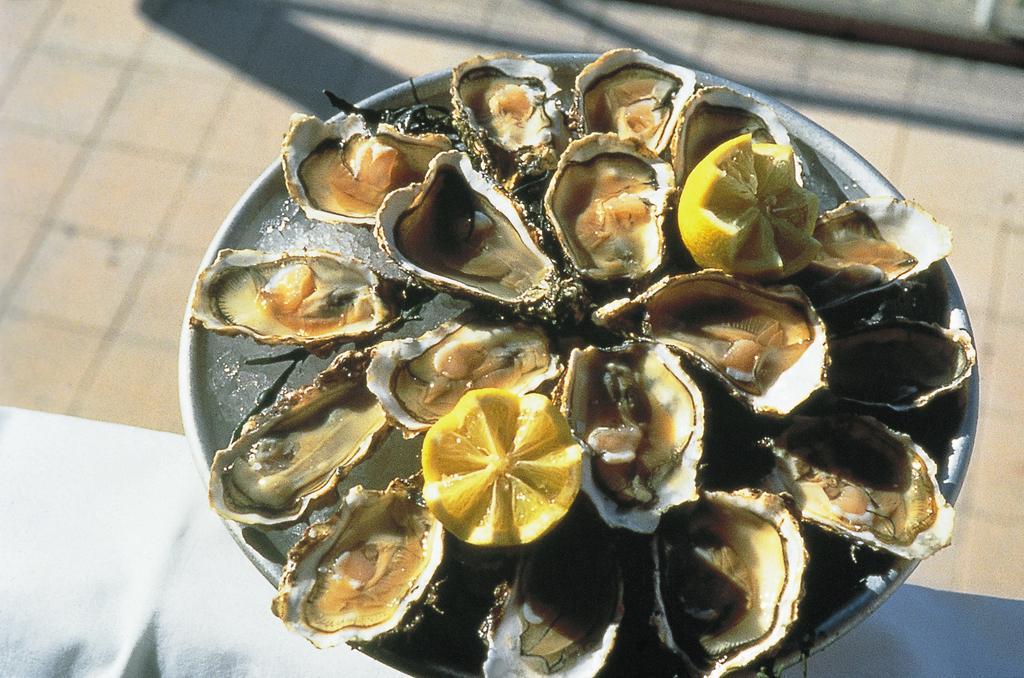In one or two sentences, can you explain what this image depicts? In this image there is a plate on which there is ice. In the ice there are shell fishes and two lemon pieces. 